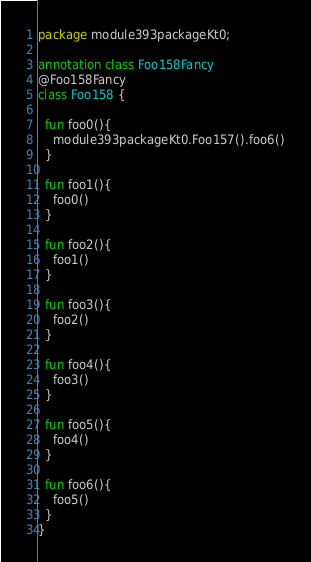Convert code to text. <code><loc_0><loc_0><loc_500><loc_500><_Kotlin_>package module393packageKt0;

annotation class Foo158Fancy
@Foo158Fancy
class Foo158 {

  fun foo0(){
    module393packageKt0.Foo157().foo6()
  }

  fun foo1(){
    foo0()
  }

  fun foo2(){
    foo1()
  }

  fun foo3(){
    foo2()
  }

  fun foo4(){
    foo3()
  }

  fun foo5(){
    foo4()
  }

  fun foo6(){
    foo5()
  }
}</code> 